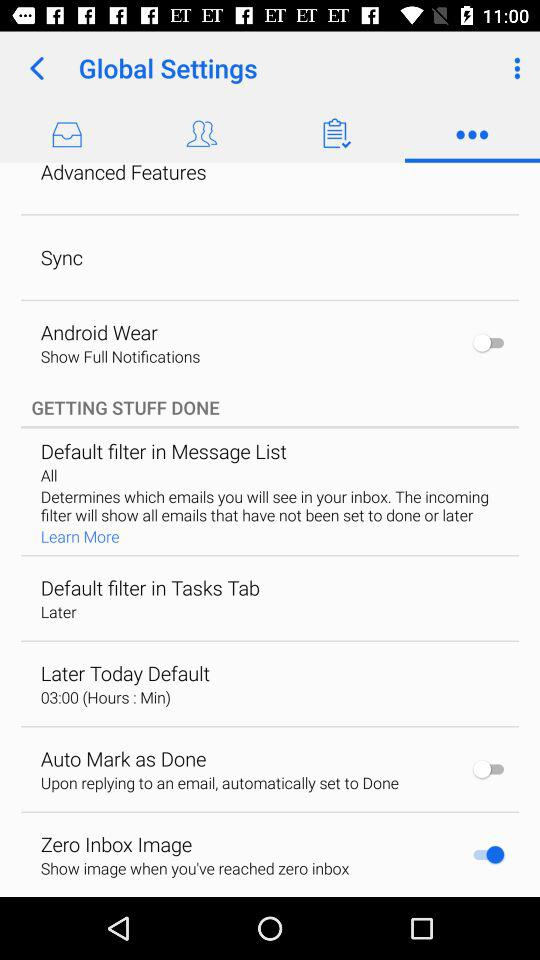What is the setting for "Android Wear"? The setting is "Show Full Notifications". 